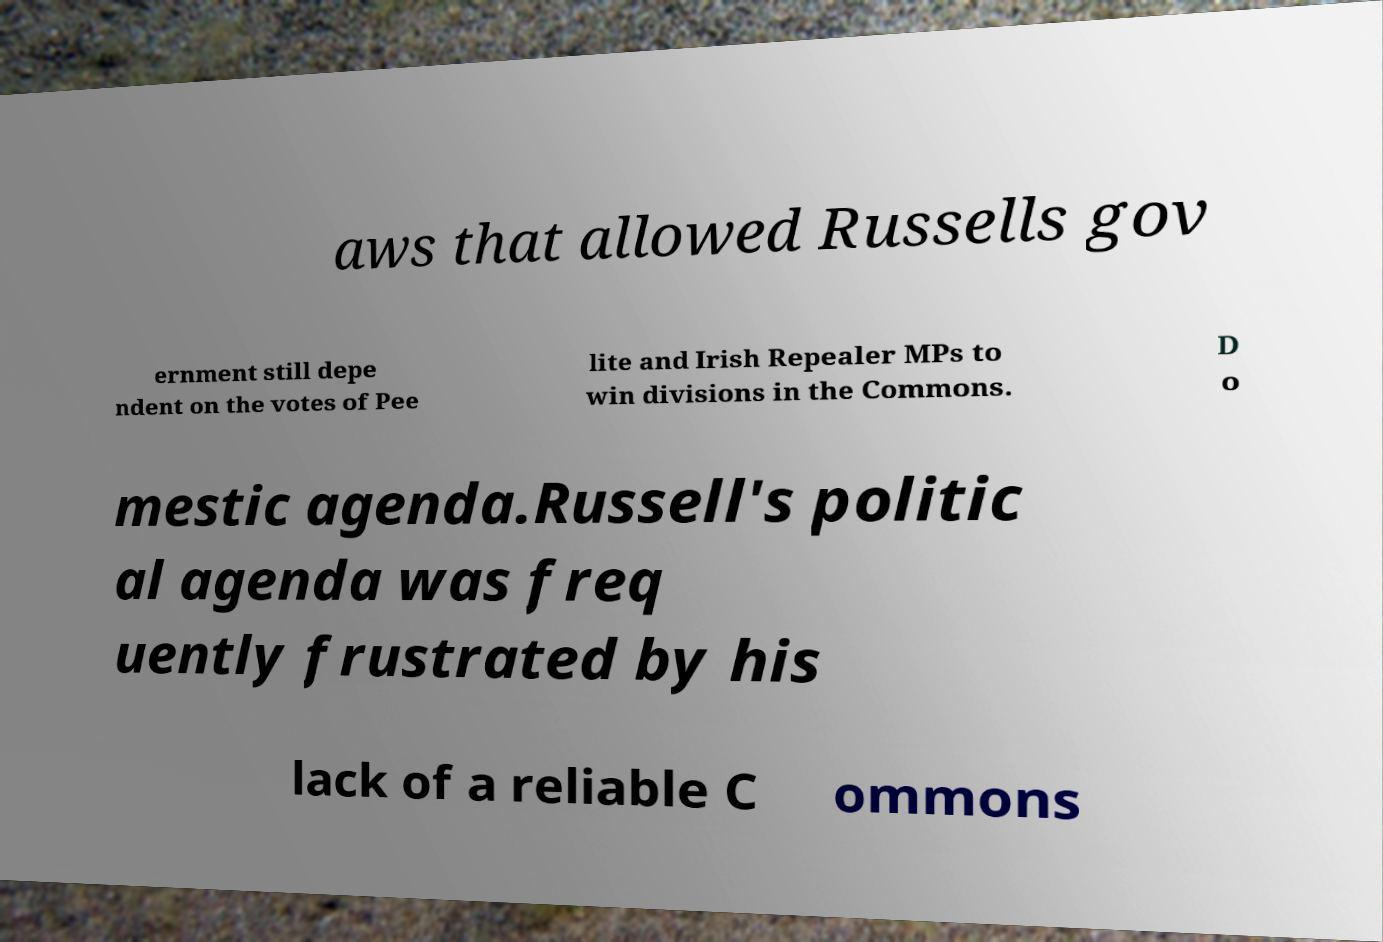Can you read and provide the text displayed in the image?This photo seems to have some interesting text. Can you extract and type it out for me? aws that allowed Russells gov ernment still depe ndent on the votes of Pee lite and Irish Repealer MPs to win divisions in the Commons. D o mestic agenda.Russell's politic al agenda was freq uently frustrated by his lack of a reliable C ommons 